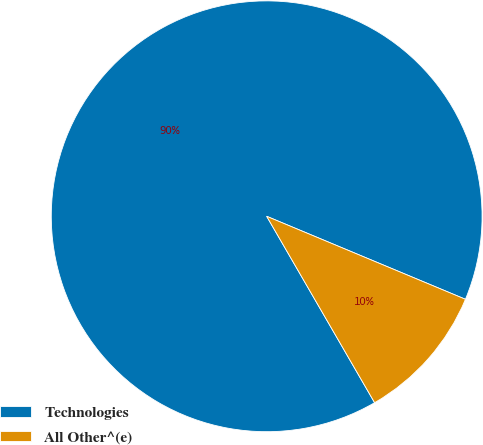Convert chart to OTSL. <chart><loc_0><loc_0><loc_500><loc_500><pie_chart><fcel>Technologies<fcel>All Other^(e)<nl><fcel>89.65%<fcel>10.35%<nl></chart> 